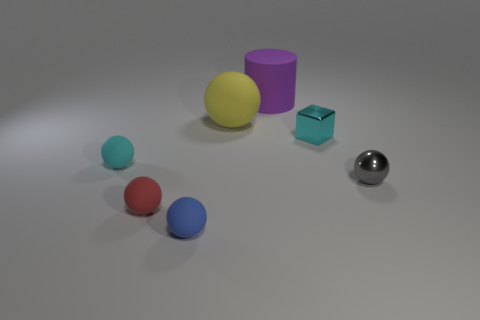Subtract all cyan balls. How many balls are left? 4 Subtract all brown balls. Subtract all gray blocks. How many balls are left? 5 Add 1 tiny gray balls. How many objects exist? 8 Subtract all spheres. How many objects are left? 2 Subtract all small matte things. Subtract all metallic objects. How many objects are left? 2 Add 1 large yellow rubber objects. How many large yellow rubber objects are left? 2 Add 2 red rubber balls. How many red rubber balls exist? 3 Subtract 0 red blocks. How many objects are left? 7 